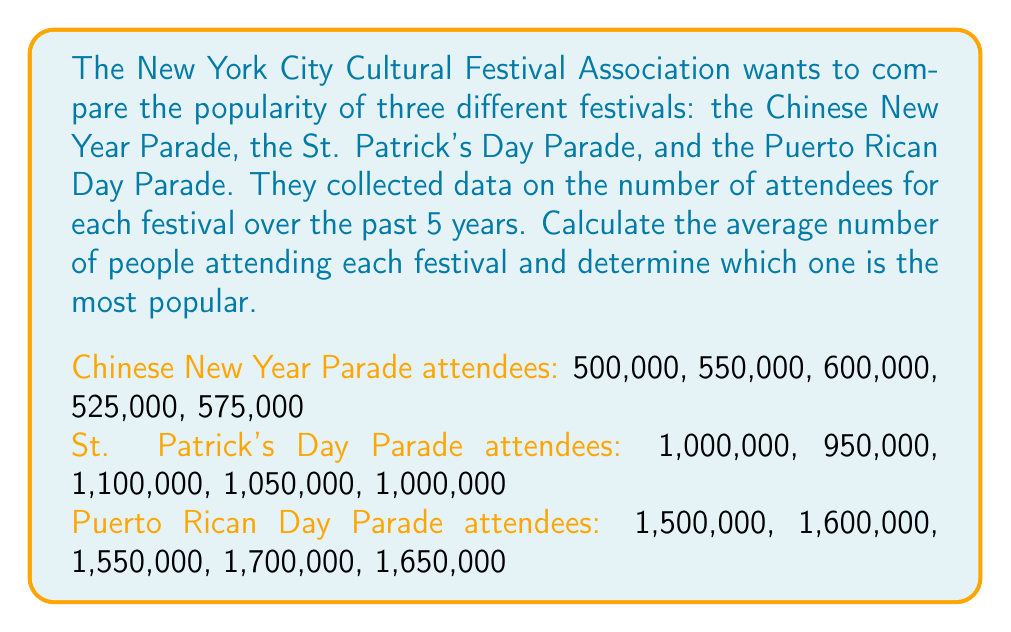Could you help me with this problem? To solve this problem, we need to calculate the average (mean) number of attendees for each festival. Let's go through it step by step:

1. Calculate the average for the Chinese New Year Parade:
   Sum of attendees: $500,000 + 550,000 + 600,000 + 525,000 + 575,000 = 2,750,000$
   Average: $\frac{2,750,000}{5} = 550,000$

2. Calculate the average for the St. Patrick's Day Parade:
   Sum of attendees: $1,000,000 + 950,000 + 1,100,000 + 1,050,000 + 1,000,000 = 5,100,000$
   Average: $\frac{5,100,000}{5} = 1,020,000$

3. Calculate the average for the Puerto Rican Day Parade:
   Sum of attendees: $1,500,000 + 1,600,000 + 1,550,000 + 1,700,000 + 1,650,000 = 8,000,000$
   Average: $\frac{8,000,000}{5} = 1,600,000$

4. Compare the averages:
   Chinese New Year Parade: 550,000
   St. Patrick's Day Parade: 1,020,000
   Puerto Rican Day Parade: 1,600,000

The Puerto Rican Day Parade has the highest average attendance, making it the most popular among the three festivals.
Answer: Puerto Rican Day Parade, with an average attendance of 1,600,000 people. 